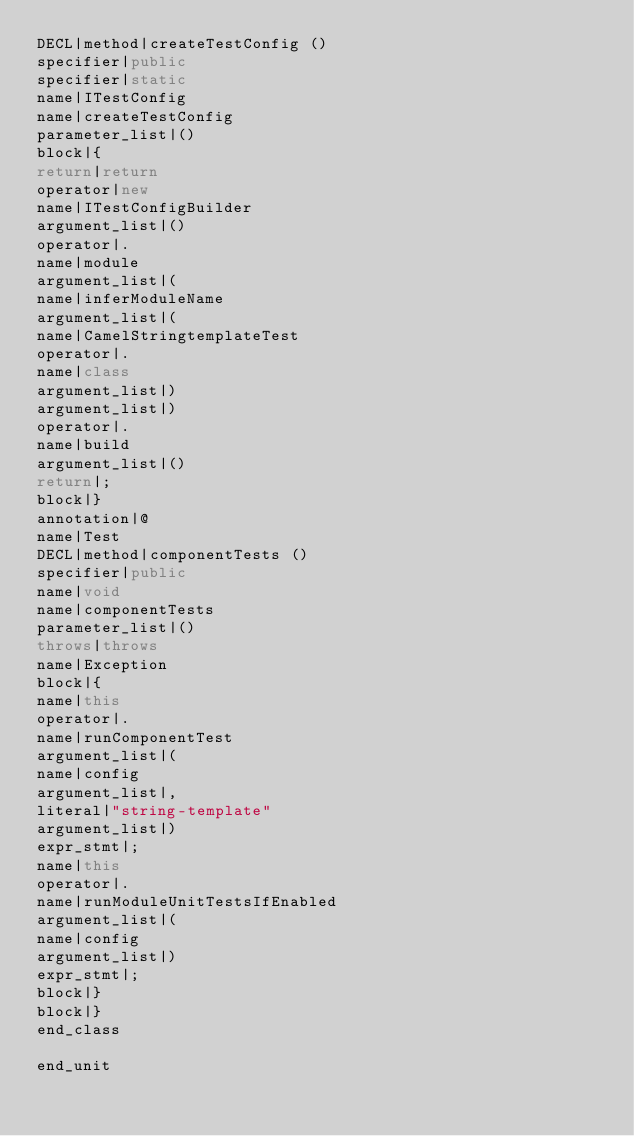<code> <loc_0><loc_0><loc_500><loc_500><_Java_>DECL|method|createTestConfig ()
specifier|public
specifier|static
name|ITestConfig
name|createTestConfig
parameter_list|()
block|{
return|return
operator|new
name|ITestConfigBuilder
argument_list|()
operator|.
name|module
argument_list|(
name|inferModuleName
argument_list|(
name|CamelStringtemplateTest
operator|.
name|class
argument_list|)
argument_list|)
operator|.
name|build
argument_list|()
return|;
block|}
annotation|@
name|Test
DECL|method|componentTests ()
specifier|public
name|void
name|componentTests
parameter_list|()
throws|throws
name|Exception
block|{
name|this
operator|.
name|runComponentTest
argument_list|(
name|config
argument_list|,
literal|"string-template"
argument_list|)
expr_stmt|;
name|this
operator|.
name|runModuleUnitTestsIfEnabled
argument_list|(
name|config
argument_list|)
expr_stmt|;
block|}
block|}
end_class

end_unit

</code> 